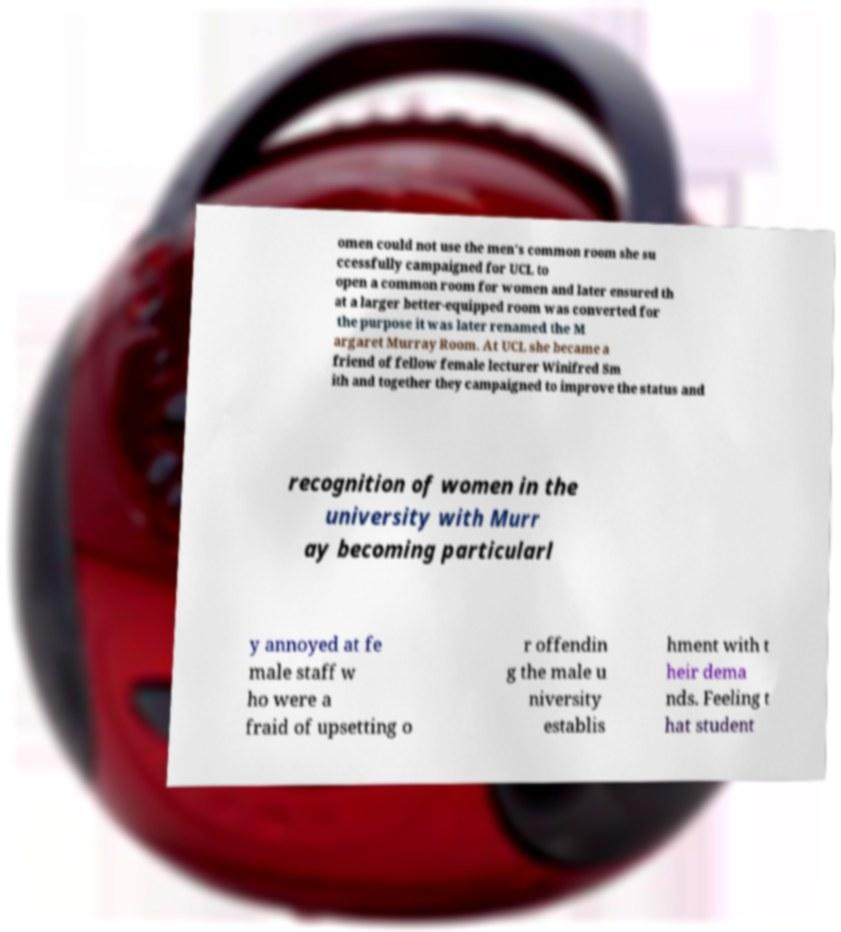Can you read and provide the text displayed in the image?This photo seems to have some interesting text. Can you extract and type it out for me? omen could not use the men's common room she su ccessfully campaigned for UCL to open a common room for women and later ensured th at a larger better-equipped room was converted for the purpose it was later renamed the M argaret Murray Room. At UCL she became a friend of fellow female lecturer Winifred Sm ith and together they campaigned to improve the status and recognition of women in the university with Murr ay becoming particularl y annoyed at fe male staff w ho were a fraid of upsetting o r offendin g the male u niversity establis hment with t heir dema nds. Feeling t hat student 